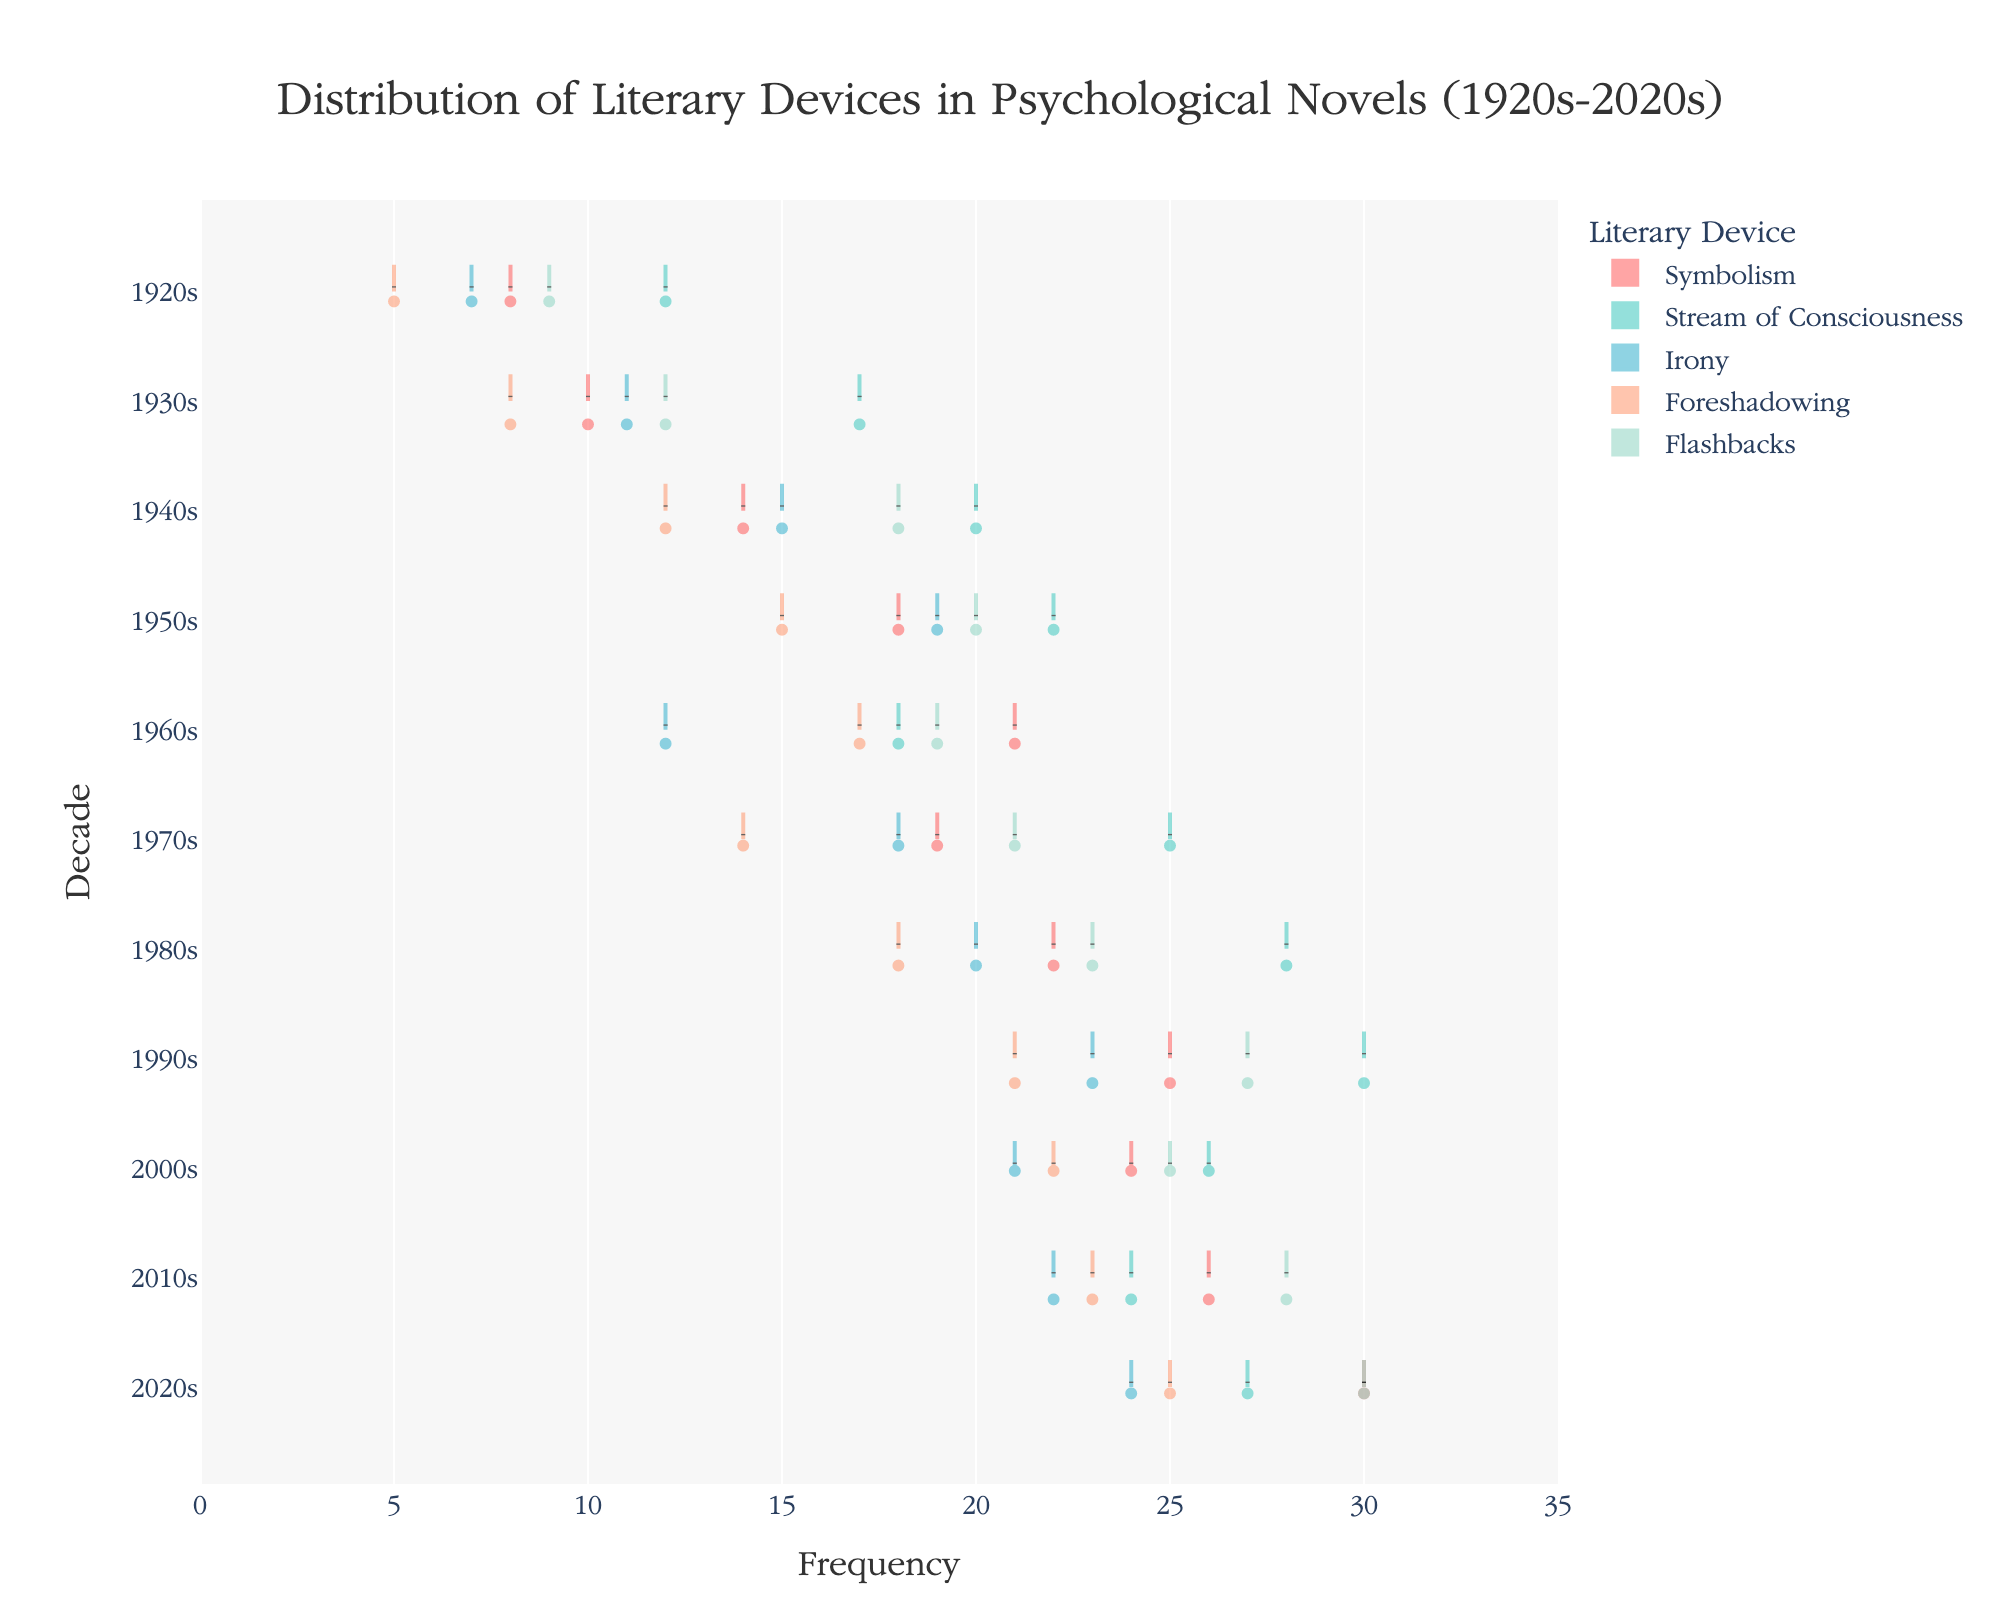What's the title of the figure? The title is located at the top of the graph, typically centered and prominently displayed. The title for this graph is "Distribution of Literary Devices in Psychological Novels (1920s-2020s)".
Answer: Distribution of Literary Devices in Psychological Novels (1920s-2020s) Which literary device has the highest frequency in the 2020s? To find this, locate the 2020s on the y-axis and look for the highest point on the x-axis within that row. Flashbacks reach the highest frequency in the 2020s.
Answer: Flashbacks What is the trend in the usage of Stream of Consciousness across the decades? Follow the Stream of Consciousness line from the 1920s through to the 2020s to observe the change. The frequency increases steadily, slightly fluctuates in the 1960s, increases again, has a peak around the 1990s, and then varies moderately till the 2020s.
Answer: Increasing with some fluctuations Which decade did Irony experience a drop in frequency after an increase? Check the Irony data points on the y-axis from decade to decade. Notice an increase from the 1940s to the 1950s, followed by a decrease in the 1960s.
Answer: 1960s In which decade did Foreshadowing first surpass a frequency of 20? Track the vertical line of Foreshadowing to see where its values exceed 20. The 1990s is the first decade where Foreshadowing surpasses a frequency of 20.
Answer: 1990s Compare the mean frequency of Symbolism and Foreshadowing in the 1950s. Which is higher? Look at the mean lines for Symbolism and Foreshadowing in the 1950s. Symbolism has a mean frequency of 18, and Foreshadowing has 15. Therefore, mean frequency for Symbolism is higher.
Answer: Symbolism What can you infer about the variability of Flashbacks compared to Symbolism? Assess the width of the violins: wider shapes at a particular y-level indicate more variability. Flashbacks have broader sections compared to Symbolism, indicating higher variability.
Answer: Flashbacks have higher variability How did the distribution of Symbolism change between the 1920s and 2020s? Compare the Symbolism violin plots for the 1920s and the 2020s. In the 1920s, the frequency is concentrated lower and narrow, whereas in the 2020s, it's higher and wider, indicating increased use and variability.
Answer: Increased frequency and variability What is the average increase in frequency of Irony from decade to decade? Calculate the decade to decade difference, sum them up, and divide by the number of intervals (10 decades). The individual differences are: 4, 4, 4, -7, 6, 2, 3, -2, 1, 2; the total is 17. So, the average increase is approximately 1.7 per decade.
Answer: 1.7 